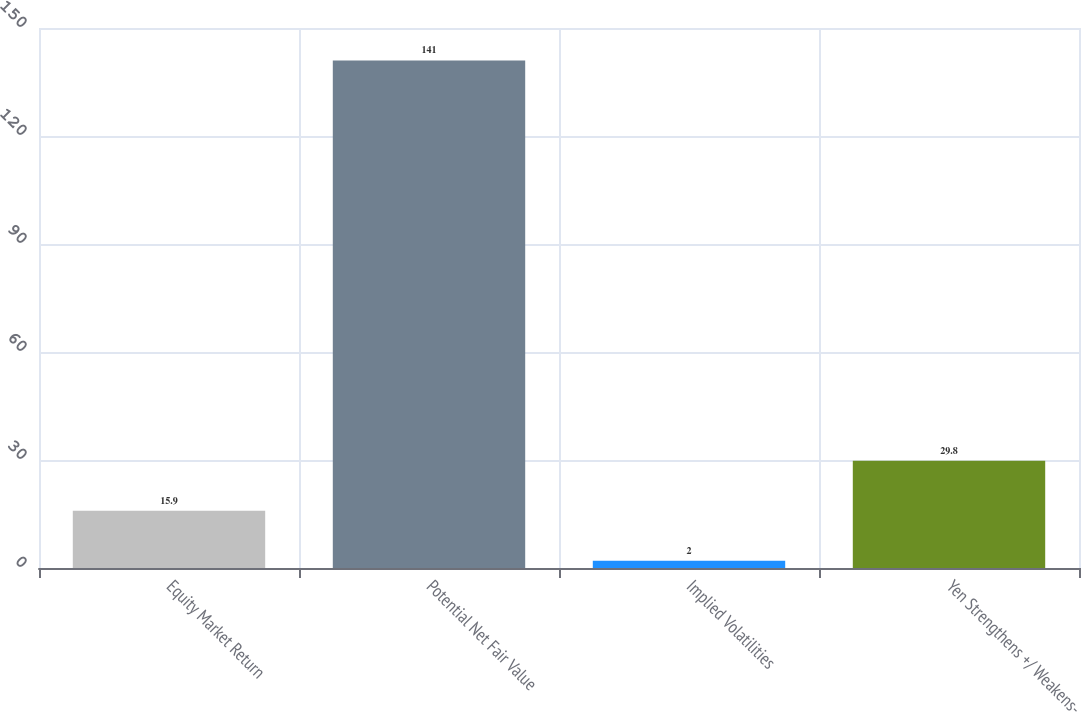Convert chart. <chart><loc_0><loc_0><loc_500><loc_500><bar_chart><fcel>Equity Market Return<fcel>Potential Net Fair Value<fcel>Implied Volatilities<fcel>Yen Strengthens +/ Weakens-<nl><fcel>15.9<fcel>141<fcel>2<fcel>29.8<nl></chart> 